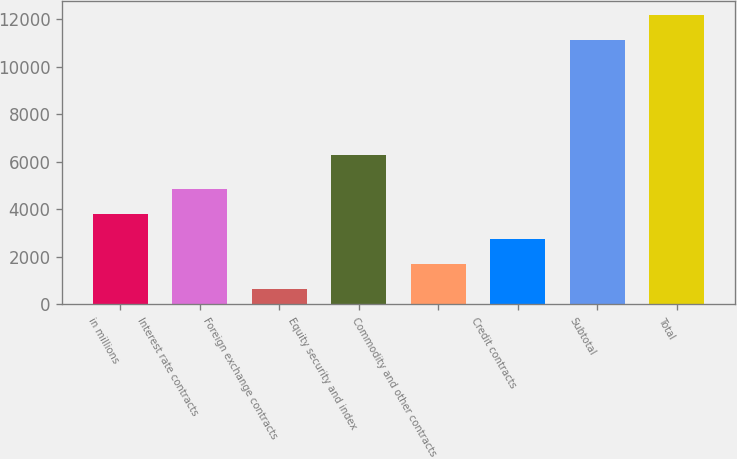Convert chart to OTSL. <chart><loc_0><loc_0><loc_500><loc_500><bar_chart><fcel>in millions<fcel>Interest rate contracts<fcel>Foreign exchange contracts<fcel>Equity security and index<fcel>Commodity and other contracts<fcel>Credit contracts<fcel>Subtotal<fcel>Total<nl><fcel>3787.7<fcel>4834.6<fcel>647<fcel>6291<fcel>1693.9<fcel>2740.8<fcel>11116<fcel>12162.9<nl></chart> 